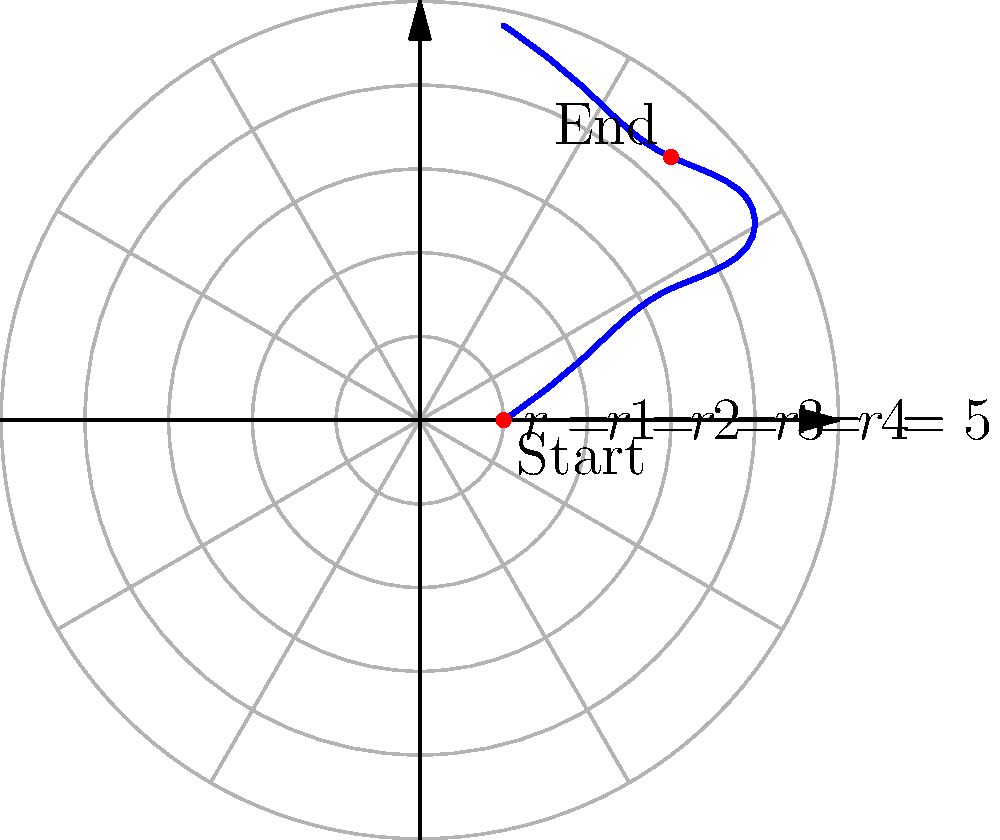An accessible bus line follows a route plotted on a polar grid, starting at $(r,\theta) = (1,0)$ and ending at $(r,\theta) = (3,\pi)$. The route passes through points $(2,\frac{\pi}{4})$, $(3,\frac{\pi}{2})$, $(4,\frac{3\pi}{4})$, and $(2,\frac{5\pi}{4})$. What is the total angular distance (in radians) traveled by the bus from start to finish? To find the total angular distance traveled, we need to sum up the changes in angle between consecutive points:

1) From $(1,0)$ to $(2,\frac{\pi}{4})$: $\Delta\theta_1 = \frac{\pi}{4} - 0 = \frac{\pi}{4}$

2) From $(2,\frac{\pi}{4})$ to $(3,\frac{\pi}{2})$: $\Delta\theta_2 = \frac{\pi}{2} - \frac{\pi}{4} = \frac{\pi}{4}$

3) From $(3,\frac{\pi}{2})$ to $(4,\frac{3\pi}{4})$: $\Delta\theta_3 = \frac{3\pi}{4} - \frac{\pi}{2} = \frac{\pi}{4}$

4) From $(4,\frac{3\pi}{4})$ to $(3,\pi)$: $\Delta\theta_4 = \pi - \frac{3\pi}{4} = \frac{\pi}{4}$

5) From $(3,\pi)$ to $(2,\frac{5\pi}{4})$: $\Delta\theta_5 = \frac{5\pi}{4} - \pi = \frac{\pi}{4}$

6) From $(2,\frac{5\pi}{4})$ to $(1,\frac{3\pi}{2})$: $\Delta\theta_6 = \frac{3\pi}{2} - \frac{5\pi}{4} = \frac{\pi}{4}$

Total angular distance = $\sum_{i=1}^6 \Delta\theta_i = 6 \cdot \frac{\pi}{4} = \frac{3\pi}{2}$ radians
Answer: $\frac{3\pi}{2}$ radians 